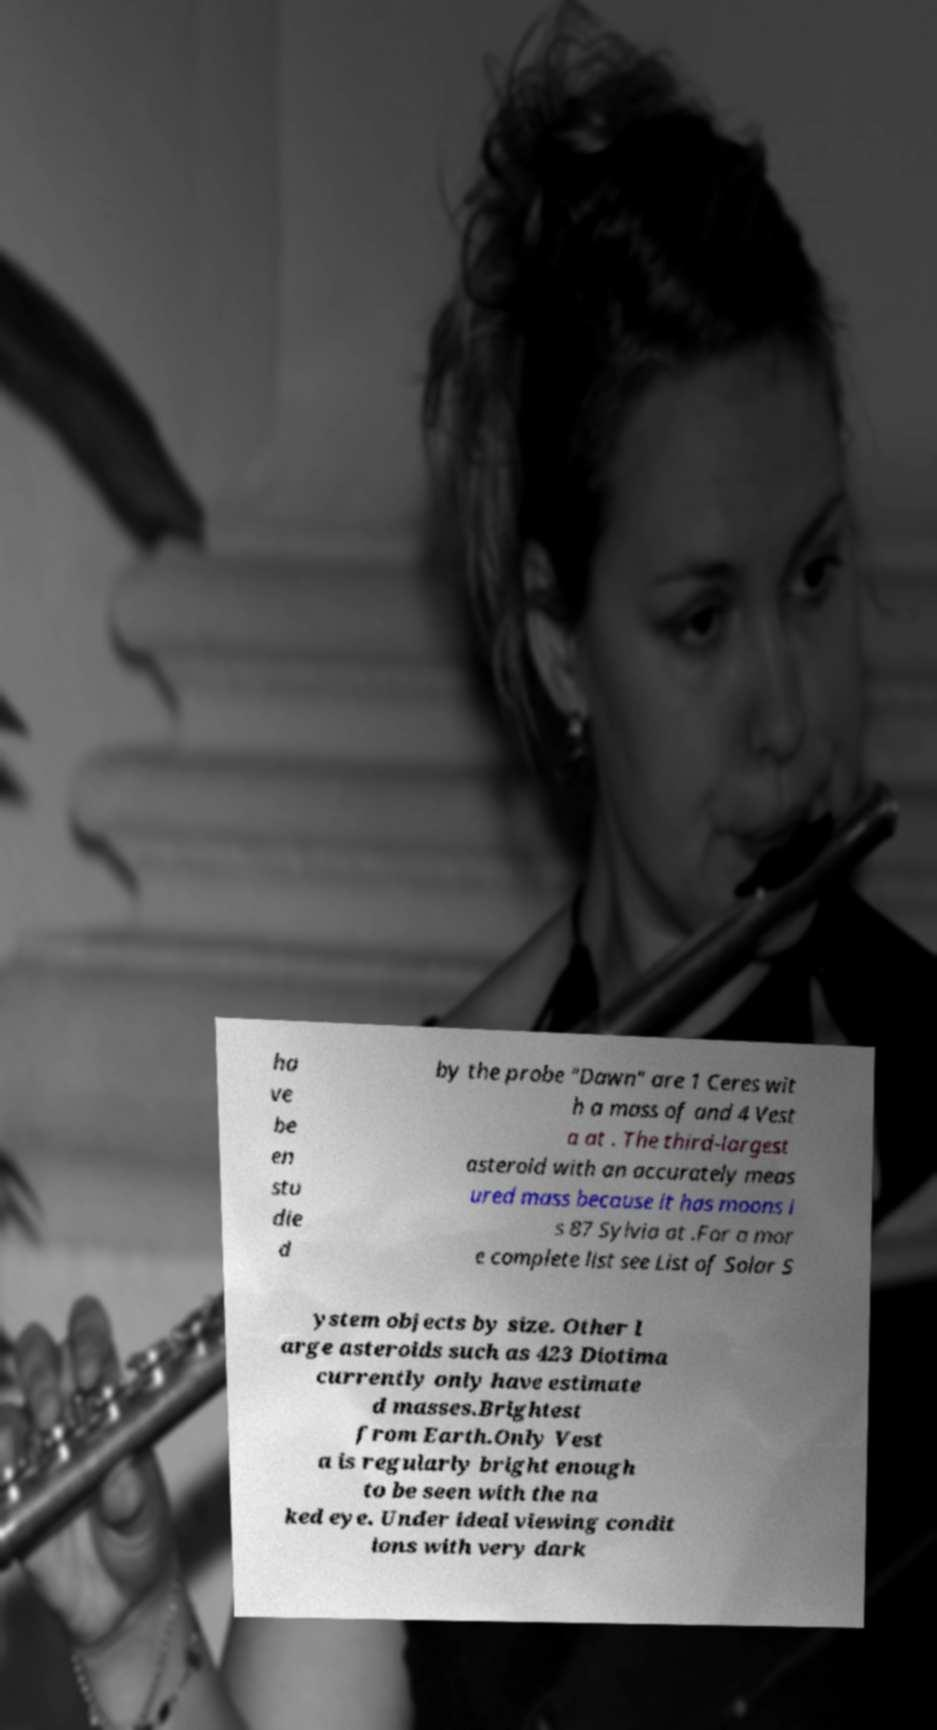Please identify and transcribe the text found in this image. ha ve be en stu die d by the probe "Dawn" are 1 Ceres wit h a mass of and 4 Vest a at . The third-largest asteroid with an accurately meas ured mass because it has moons i s 87 Sylvia at .For a mor e complete list see List of Solar S ystem objects by size. Other l arge asteroids such as 423 Diotima currently only have estimate d masses.Brightest from Earth.Only Vest a is regularly bright enough to be seen with the na ked eye. Under ideal viewing condit ions with very dark 